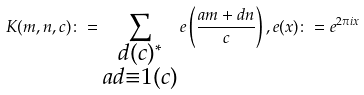<formula> <loc_0><loc_0><loc_500><loc_500>K ( m , n , c ) \colon = \sum _ { \substack { d ( c ) ^ { * } \\ a d \equiv 1 ( c ) } } e \left ( \frac { a m + d n } { c } \right ) , e ( x ) \colon = e ^ { 2 \pi i x }</formula> 